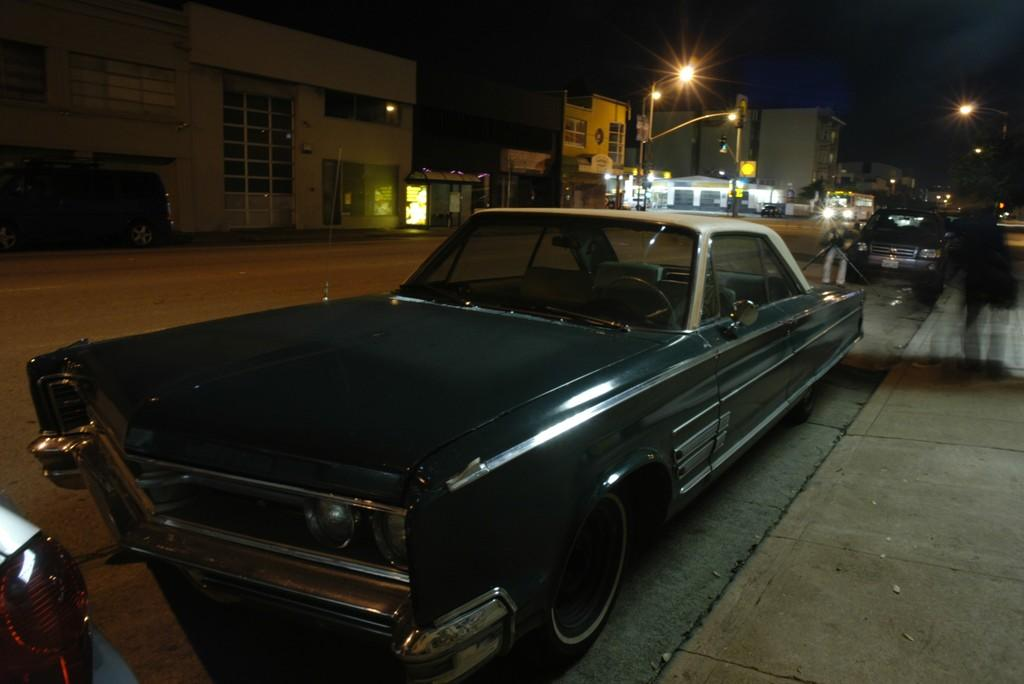What type of view is shown in the image? The image is an outside view. What can be seen in the middle of the image? There is a car in the middle of the image. What structures are visible in the background of the image? There are buildings visible in the image. What objects are present at the top of the image? Street poles are present at the top of the image. What company is responsible for the car in the image? The image does not provide information about the car's manufacturer or any company affiliation. 